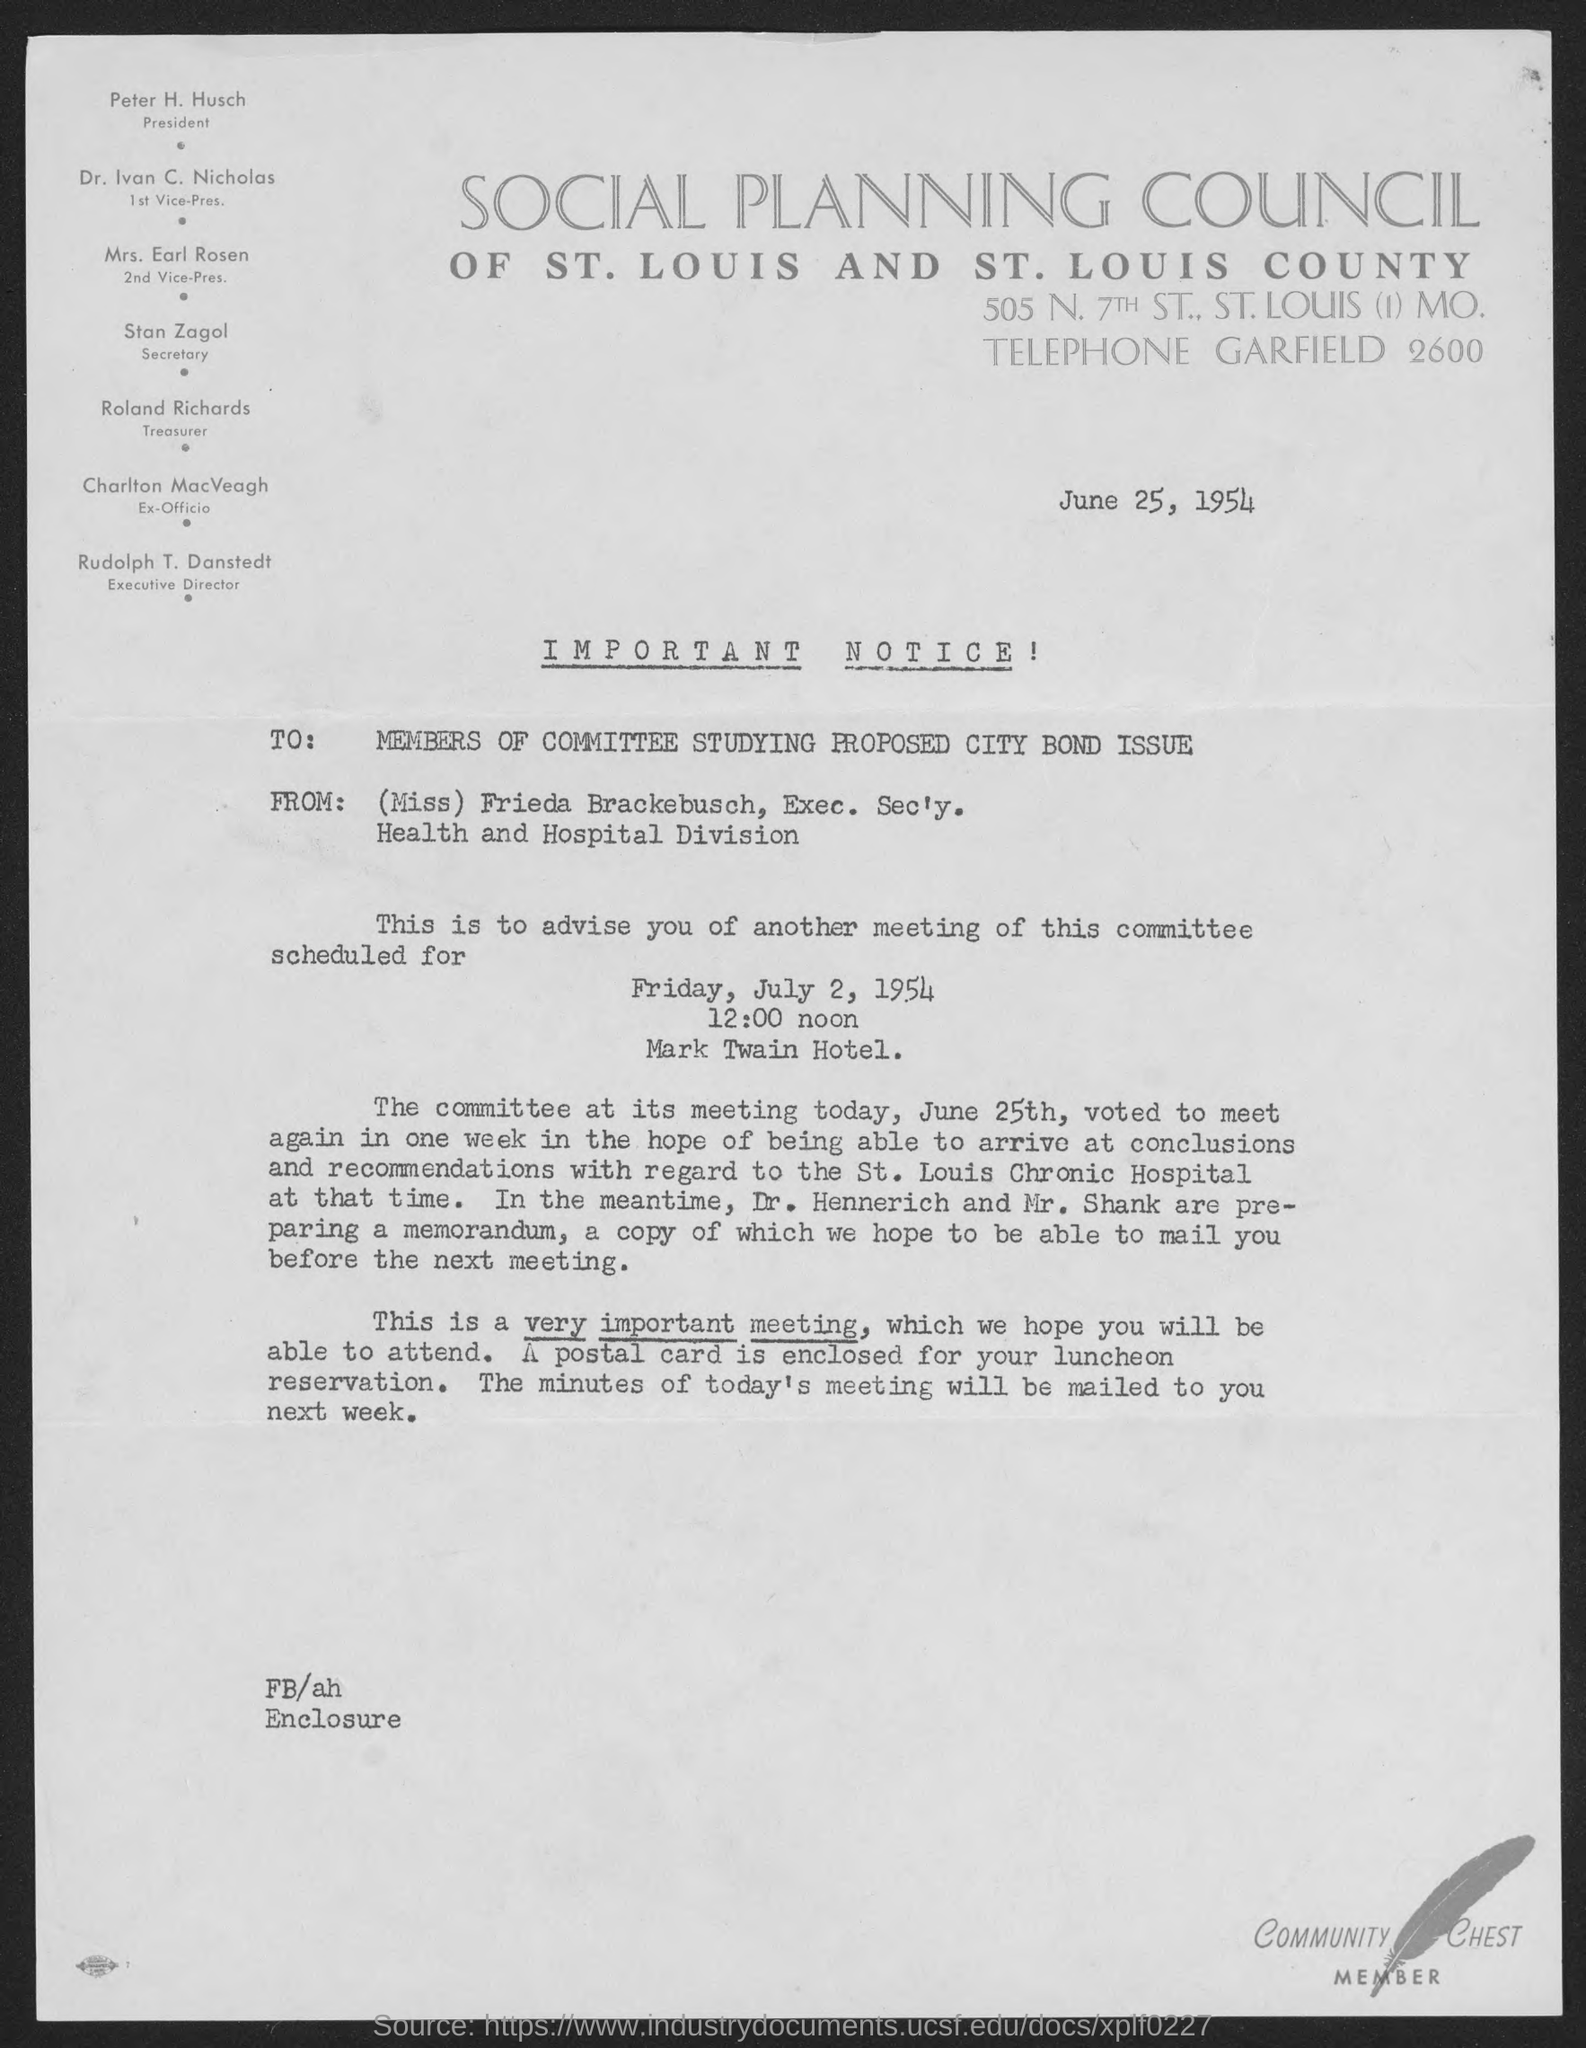What is the street address of social planning council of st. louis and st. louis county ?
Ensure brevity in your answer.  505 n. 7th st. Who is the president of social planning council of st. louis and st. louis county?
Keep it short and to the point. Peter h. husch. Who is the 1st vice-pres. of social planning council of st.louis and st. louis county?
Your answer should be very brief. Dr. Ivan C. Nicholas. Who is the 2nd vice-pres. of social planning council of st. louis and st. louis county?
Offer a terse response. Mrs. earl rosen. Who is the treasurer of social planning council of st. louis and st. louis county?
Make the answer very short. Roland richards. Who is the ex- officio of social planning council of st. louis and st. louis county?
Offer a very short reply. Charlton MacVeagh. Who is the executive director of social planning council of st. louis and st. louis county?
Make the answer very short. Rudolph t. danstedt. When is the notice dated on?
Your answer should be compact. June 25, 1954. Who is the exec. sec'y. of health and hospital division ?
Provide a succinct answer. (miss) frieda brackebusch. 